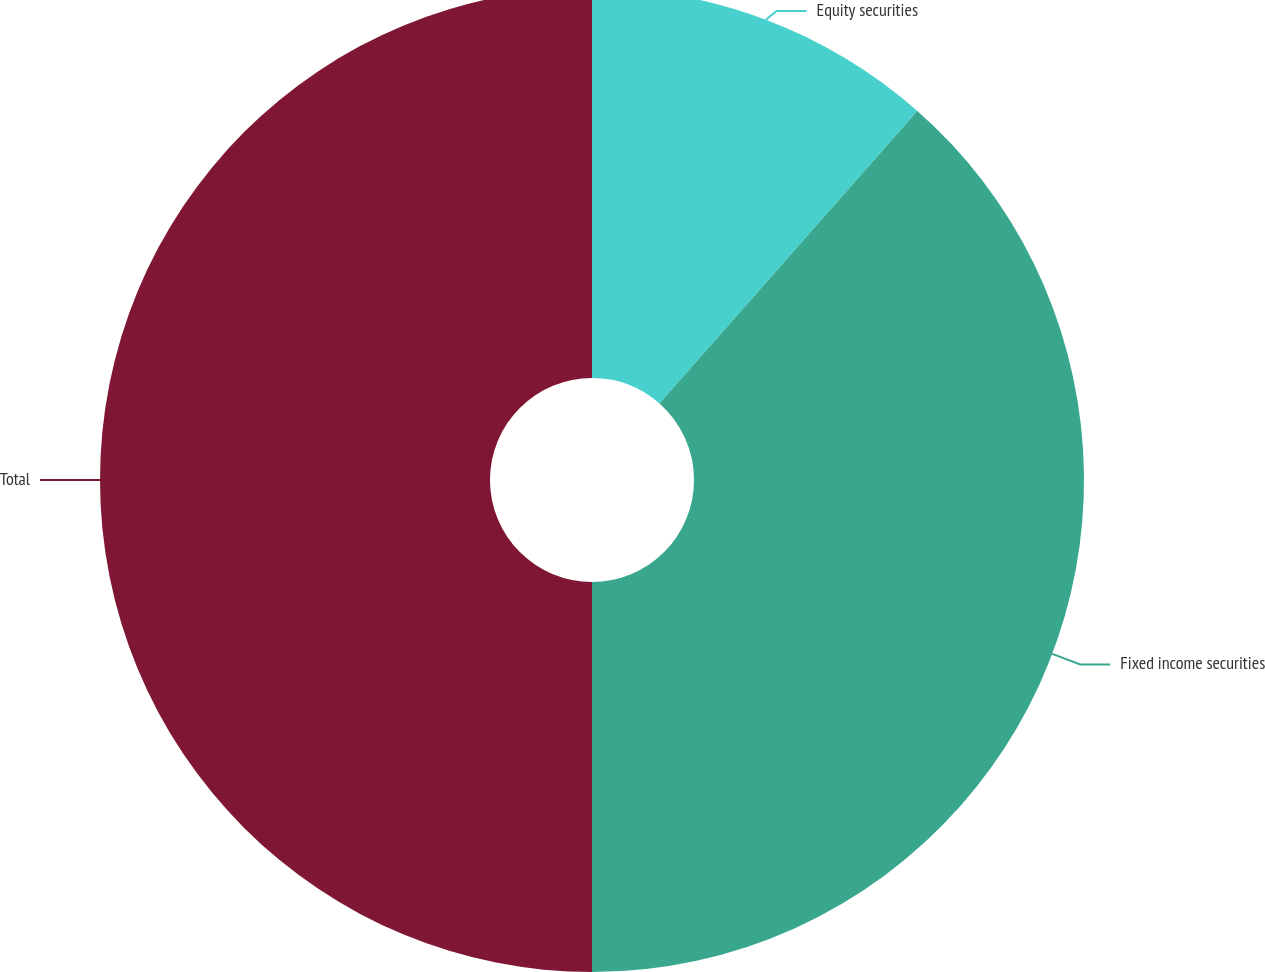<chart> <loc_0><loc_0><loc_500><loc_500><pie_chart><fcel>Equity securities<fcel>Fixed income securities<fcel>Total<nl><fcel>11.5%<fcel>38.5%<fcel>50.0%<nl></chart> 